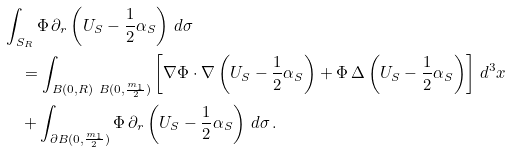Convert formula to latex. <formula><loc_0><loc_0><loc_500><loc_500>& \int _ { S _ { R } } \Phi \, \partial _ { r } \left ( U _ { S } - \frac { 1 } { 2 } \alpha _ { S } \right ) \, d \sigma \\ & \quad = \int _ { B ( 0 , R ) \ B ( 0 , \frac { m _ { 1 } } { 2 } ) } \left [ \nabla \Phi \cdot \nabla \left ( U _ { S } - \frac { 1 } { 2 } \alpha _ { S } \right ) + \Phi \, \Delta \left ( U _ { S } - \frac { 1 } { 2 } \alpha _ { S } \right ) \right ] \, d ^ { 3 } x \\ & \quad + \int _ { \partial B ( 0 , \frac { m _ { 1 } } { 2 } ) } \Phi \, \partial _ { r } \left ( U _ { S } - \frac { 1 } { 2 } \alpha _ { S } \right ) \, d \sigma \, .</formula> 